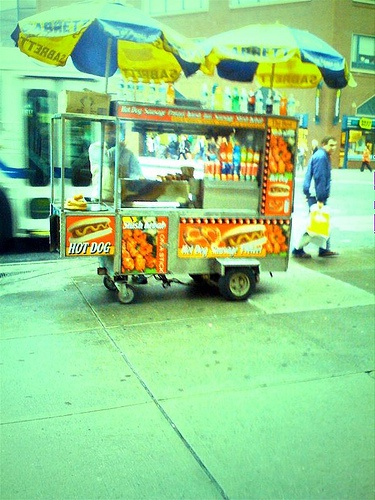Describe the objects in this image and their specific colors. I can see bus in lightgreen, aquamarine, black, and teal tones, umbrella in lightgreen, aquamarine, and yellow tones, umbrella in lightgreen, aquamarine, and yellow tones, people in lightgreen, beige, aquamarine, teal, and green tones, and people in lightgreen, teal, blue, turquoise, and lightblue tones in this image. 